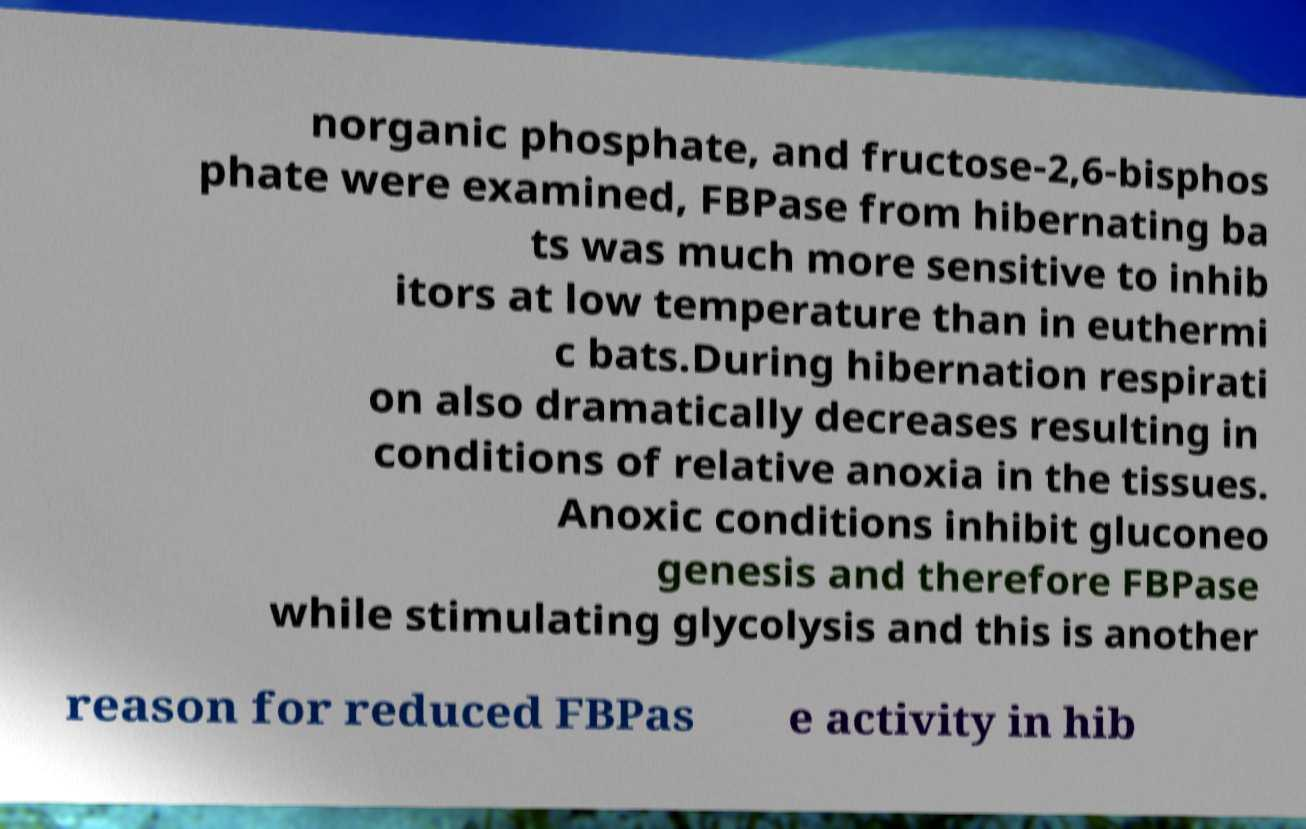Can you accurately transcribe the text from the provided image for me? norganic phosphate, and fructose-2,6-bisphos phate were examined, FBPase from hibernating ba ts was much more sensitive to inhib itors at low temperature than in euthermi c bats.During hibernation respirati on also dramatically decreases resulting in conditions of relative anoxia in the tissues. Anoxic conditions inhibit gluconeo genesis and therefore FBPase while stimulating glycolysis and this is another reason for reduced FBPas e activity in hib 